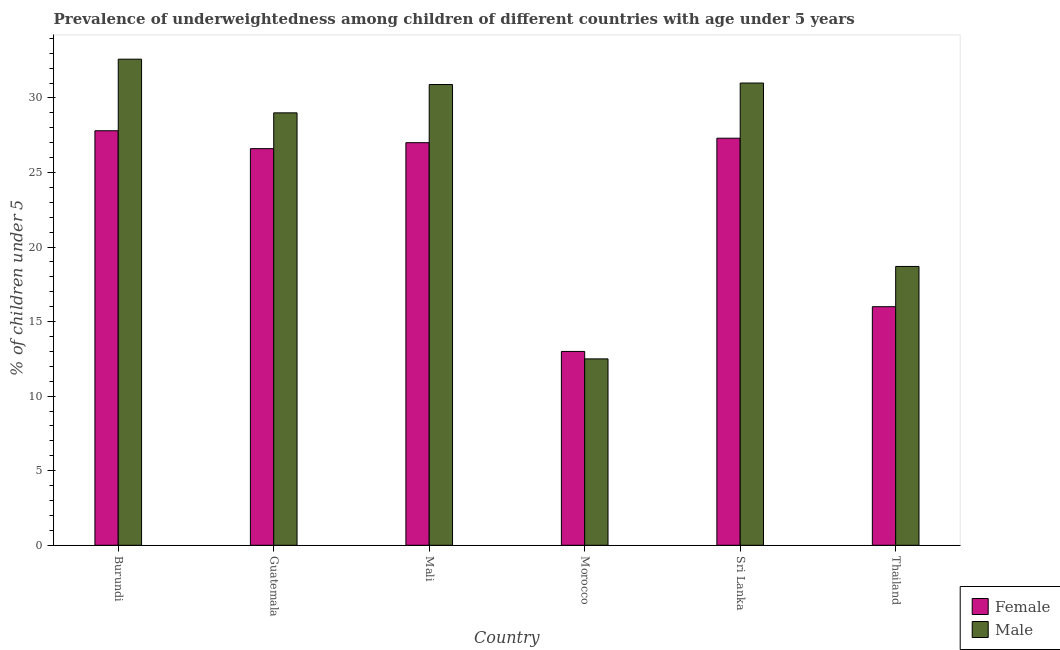How many different coloured bars are there?
Keep it short and to the point. 2. How many groups of bars are there?
Your answer should be very brief. 6. Are the number of bars per tick equal to the number of legend labels?
Keep it short and to the point. Yes. Are the number of bars on each tick of the X-axis equal?
Your response must be concise. Yes. How many bars are there on the 6th tick from the left?
Provide a short and direct response. 2. What is the label of the 2nd group of bars from the left?
Keep it short and to the point. Guatemala. What is the percentage of underweighted male children in Thailand?
Make the answer very short. 18.7. Across all countries, what is the maximum percentage of underweighted female children?
Make the answer very short. 27.8. Across all countries, what is the minimum percentage of underweighted female children?
Provide a short and direct response. 13. In which country was the percentage of underweighted male children maximum?
Provide a short and direct response. Burundi. In which country was the percentage of underweighted female children minimum?
Provide a succinct answer. Morocco. What is the total percentage of underweighted female children in the graph?
Make the answer very short. 137.7. What is the difference between the percentage of underweighted female children in Morocco and that in Thailand?
Your response must be concise. -3. What is the average percentage of underweighted male children per country?
Your response must be concise. 25.78. What is the difference between the percentage of underweighted male children and percentage of underweighted female children in Sri Lanka?
Offer a terse response. 3.7. What is the ratio of the percentage of underweighted male children in Sri Lanka to that in Thailand?
Provide a short and direct response. 1.66. Is the difference between the percentage of underweighted male children in Morocco and Thailand greater than the difference between the percentage of underweighted female children in Morocco and Thailand?
Make the answer very short. No. What is the difference between the highest and the second highest percentage of underweighted female children?
Keep it short and to the point. 0.5. What is the difference between the highest and the lowest percentage of underweighted male children?
Provide a succinct answer. 20.1. Are all the bars in the graph horizontal?
Make the answer very short. No. How many countries are there in the graph?
Your answer should be compact. 6. Does the graph contain any zero values?
Provide a short and direct response. No. Does the graph contain grids?
Keep it short and to the point. No. Where does the legend appear in the graph?
Give a very brief answer. Bottom right. How are the legend labels stacked?
Offer a terse response. Vertical. What is the title of the graph?
Keep it short and to the point. Prevalence of underweightedness among children of different countries with age under 5 years. Does "Methane emissions" appear as one of the legend labels in the graph?
Provide a short and direct response. No. What is the label or title of the Y-axis?
Make the answer very short.  % of children under 5. What is the  % of children under 5 of Female in Burundi?
Provide a succinct answer. 27.8. What is the  % of children under 5 in Male in Burundi?
Provide a succinct answer. 32.6. What is the  % of children under 5 in Female in Guatemala?
Your answer should be compact. 26.6. What is the  % of children under 5 in Male in Guatemala?
Offer a very short reply. 29. What is the  % of children under 5 of Female in Mali?
Make the answer very short. 27. What is the  % of children under 5 in Male in Mali?
Give a very brief answer. 30.9. What is the  % of children under 5 of Female in Morocco?
Keep it short and to the point. 13. What is the  % of children under 5 of Female in Sri Lanka?
Provide a succinct answer. 27.3. What is the  % of children under 5 in Male in Sri Lanka?
Provide a short and direct response. 31. What is the  % of children under 5 of Female in Thailand?
Keep it short and to the point. 16. What is the  % of children under 5 in Male in Thailand?
Your response must be concise. 18.7. Across all countries, what is the maximum  % of children under 5 in Female?
Your response must be concise. 27.8. Across all countries, what is the maximum  % of children under 5 in Male?
Your answer should be compact. 32.6. Across all countries, what is the minimum  % of children under 5 of Female?
Provide a succinct answer. 13. Across all countries, what is the minimum  % of children under 5 in Male?
Your response must be concise. 12.5. What is the total  % of children under 5 in Female in the graph?
Offer a very short reply. 137.7. What is the total  % of children under 5 of Male in the graph?
Give a very brief answer. 154.7. What is the difference between the  % of children under 5 in Female in Burundi and that in Guatemala?
Ensure brevity in your answer.  1.2. What is the difference between the  % of children under 5 of Male in Burundi and that in Guatemala?
Keep it short and to the point. 3.6. What is the difference between the  % of children under 5 in Male in Burundi and that in Morocco?
Give a very brief answer. 20.1. What is the difference between the  % of children under 5 of Female in Burundi and that in Sri Lanka?
Your answer should be compact. 0.5. What is the difference between the  % of children under 5 in Male in Burundi and that in Thailand?
Offer a terse response. 13.9. What is the difference between the  % of children under 5 in Male in Guatemala and that in Mali?
Keep it short and to the point. -1.9. What is the difference between the  % of children under 5 in Female in Guatemala and that in Sri Lanka?
Ensure brevity in your answer.  -0.7. What is the difference between the  % of children under 5 of Male in Guatemala and that in Sri Lanka?
Make the answer very short. -2. What is the difference between the  % of children under 5 of Female in Guatemala and that in Thailand?
Ensure brevity in your answer.  10.6. What is the difference between the  % of children under 5 of Male in Mali and that in Morocco?
Make the answer very short. 18.4. What is the difference between the  % of children under 5 of Male in Mali and that in Sri Lanka?
Ensure brevity in your answer.  -0.1. What is the difference between the  % of children under 5 of Male in Mali and that in Thailand?
Provide a succinct answer. 12.2. What is the difference between the  % of children under 5 of Female in Morocco and that in Sri Lanka?
Provide a succinct answer. -14.3. What is the difference between the  % of children under 5 in Male in Morocco and that in Sri Lanka?
Give a very brief answer. -18.5. What is the difference between the  % of children under 5 in Female in Sri Lanka and that in Thailand?
Keep it short and to the point. 11.3. What is the difference between the  % of children under 5 of Male in Sri Lanka and that in Thailand?
Provide a short and direct response. 12.3. What is the difference between the  % of children under 5 in Female in Burundi and the  % of children under 5 in Male in Guatemala?
Provide a short and direct response. -1.2. What is the difference between the  % of children under 5 of Female in Burundi and the  % of children under 5 of Male in Morocco?
Your response must be concise. 15.3. What is the difference between the  % of children under 5 of Female in Burundi and the  % of children under 5 of Male in Thailand?
Your answer should be compact. 9.1. What is the difference between the  % of children under 5 of Female in Guatemala and the  % of children under 5 of Male in Mali?
Give a very brief answer. -4.3. What is the difference between the  % of children under 5 in Female in Guatemala and the  % of children under 5 in Male in Thailand?
Provide a short and direct response. 7.9. What is the difference between the  % of children under 5 in Female in Morocco and the  % of children under 5 in Male in Sri Lanka?
Your answer should be very brief. -18. What is the average  % of children under 5 in Female per country?
Offer a very short reply. 22.95. What is the average  % of children under 5 of Male per country?
Keep it short and to the point. 25.78. What is the difference between the  % of children under 5 in Female and  % of children under 5 in Male in Guatemala?
Keep it short and to the point. -2.4. What is the difference between the  % of children under 5 in Female and  % of children under 5 in Male in Mali?
Ensure brevity in your answer.  -3.9. What is the ratio of the  % of children under 5 of Female in Burundi to that in Guatemala?
Provide a succinct answer. 1.05. What is the ratio of the  % of children under 5 of Male in Burundi to that in Guatemala?
Ensure brevity in your answer.  1.12. What is the ratio of the  % of children under 5 of Female in Burundi to that in Mali?
Your response must be concise. 1.03. What is the ratio of the  % of children under 5 of Male in Burundi to that in Mali?
Offer a very short reply. 1.05. What is the ratio of the  % of children under 5 of Female in Burundi to that in Morocco?
Your response must be concise. 2.14. What is the ratio of the  % of children under 5 of Male in Burundi to that in Morocco?
Keep it short and to the point. 2.61. What is the ratio of the  % of children under 5 of Female in Burundi to that in Sri Lanka?
Your response must be concise. 1.02. What is the ratio of the  % of children under 5 in Male in Burundi to that in Sri Lanka?
Offer a very short reply. 1.05. What is the ratio of the  % of children under 5 in Female in Burundi to that in Thailand?
Offer a very short reply. 1.74. What is the ratio of the  % of children under 5 of Male in Burundi to that in Thailand?
Your answer should be compact. 1.74. What is the ratio of the  % of children under 5 in Female in Guatemala to that in Mali?
Ensure brevity in your answer.  0.99. What is the ratio of the  % of children under 5 in Male in Guatemala to that in Mali?
Make the answer very short. 0.94. What is the ratio of the  % of children under 5 in Female in Guatemala to that in Morocco?
Make the answer very short. 2.05. What is the ratio of the  % of children under 5 of Male in Guatemala to that in Morocco?
Provide a short and direct response. 2.32. What is the ratio of the  % of children under 5 in Female in Guatemala to that in Sri Lanka?
Keep it short and to the point. 0.97. What is the ratio of the  % of children under 5 in Male in Guatemala to that in Sri Lanka?
Your answer should be compact. 0.94. What is the ratio of the  % of children under 5 in Female in Guatemala to that in Thailand?
Keep it short and to the point. 1.66. What is the ratio of the  % of children under 5 in Male in Guatemala to that in Thailand?
Ensure brevity in your answer.  1.55. What is the ratio of the  % of children under 5 in Female in Mali to that in Morocco?
Your answer should be very brief. 2.08. What is the ratio of the  % of children under 5 in Male in Mali to that in Morocco?
Ensure brevity in your answer.  2.47. What is the ratio of the  % of children under 5 of Male in Mali to that in Sri Lanka?
Your response must be concise. 1. What is the ratio of the  % of children under 5 of Female in Mali to that in Thailand?
Provide a succinct answer. 1.69. What is the ratio of the  % of children under 5 in Male in Mali to that in Thailand?
Give a very brief answer. 1.65. What is the ratio of the  % of children under 5 of Female in Morocco to that in Sri Lanka?
Your answer should be compact. 0.48. What is the ratio of the  % of children under 5 in Male in Morocco to that in Sri Lanka?
Keep it short and to the point. 0.4. What is the ratio of the  % of children under 5 in Female in Morocco to that in Thailand?
Make the answer very short. 0.81. What is the ratio of the  % of children under 5 in Male in Morocco to that in Thailand?
Your answer should be very brief. 0.67. What is the ratio of the  % of children under 5 of Female in Sri Lanka to that in Thailand?
Provide a short and direct response. 1.71. What is the ratio of the  % of children under 5 of Male in Sri Lanka to that in Thailand?
Your response must be concise. 1.66. What is the difference between the highest and the second highest  % of children under 5 in Female?
Keep it short and to the point. 0.5. What is the difference between the highest and the second highest  % of children under 5 of Male?
Provide a short and direct response. 1.6. What is the difference between the highest and the lowest  % of children under 5 in Female?
Your answer should be very brief. 14.8. What is the difference between the highest and the lowest  % of children under 5 in Male?
Your answer should be very brief. 20.1. 